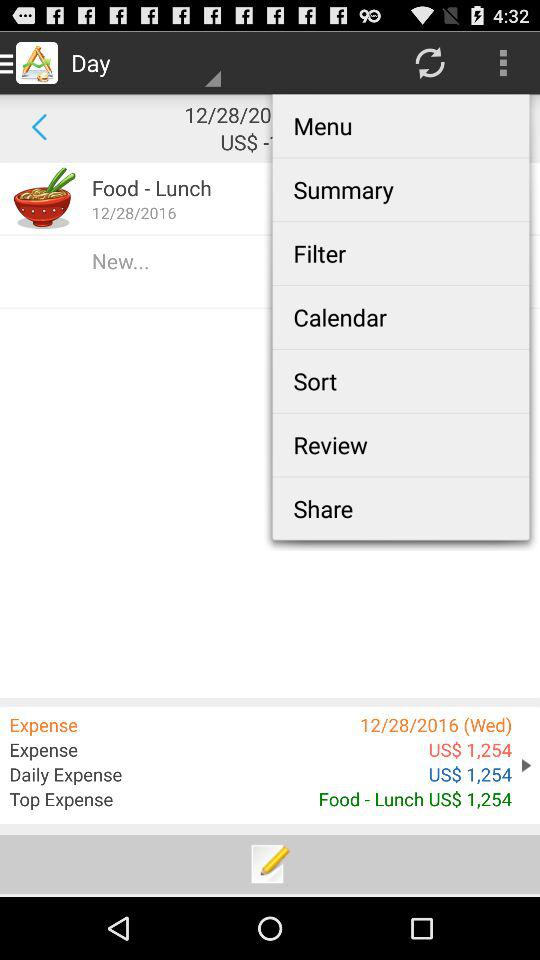What is the top expense? The top expense is $1,254 on lunch food. 